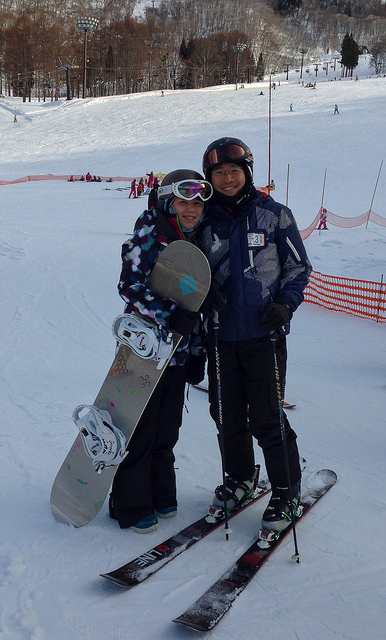Identify the text contained in this image. LINE 